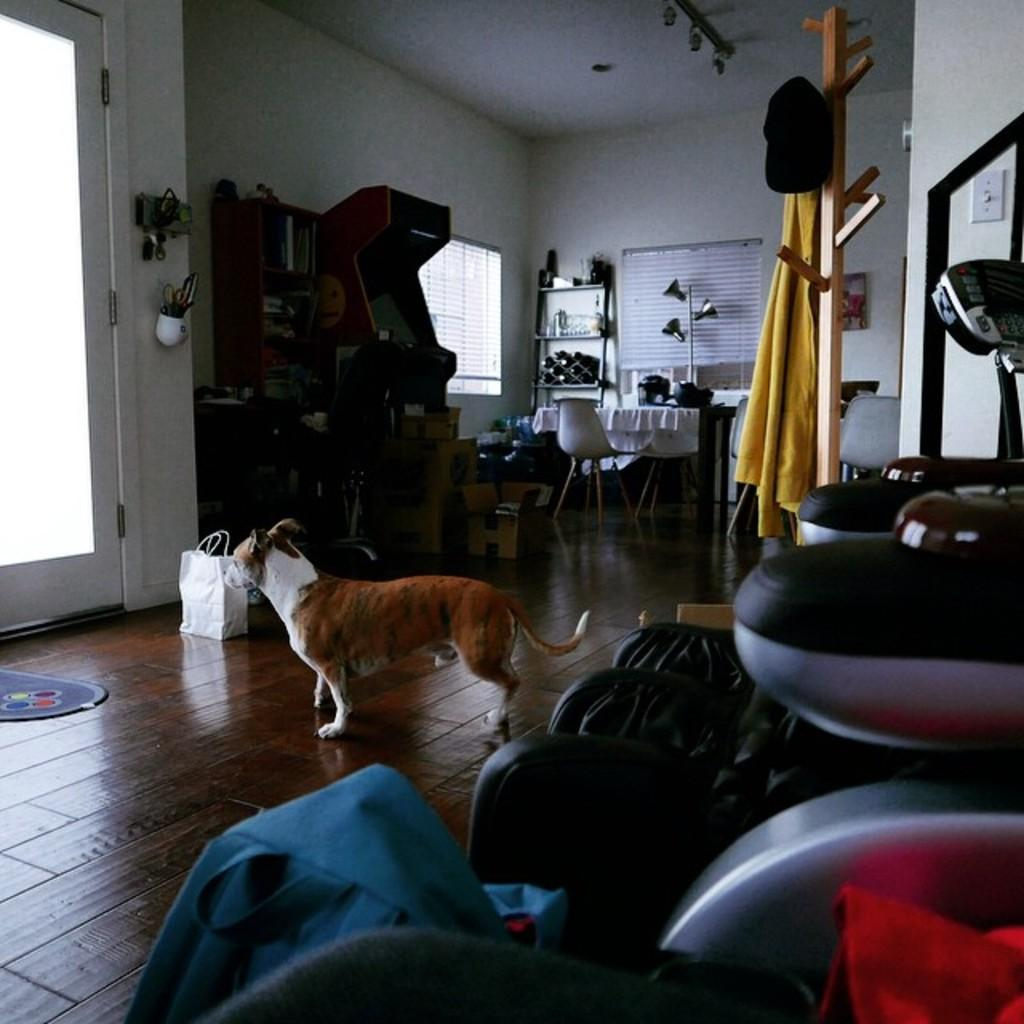What animal can be seen on the floor in the image? There is a dog on the floor in the image. What type of object is present in the image that can be used for carrying items? There is a bag in the image that can be used for carrying items. What type of furniture is visible in the image? There is a chair and a table in the image. What type of material is present in the image? There is cloth in the image. What type of clothing accessory is present in the image? There is a cap in the image. What type of storage or shelving is present in the image? There are racks in the image. What type of opening is present in the image that allows light and air to enter? There is a window in the image. What type of entrance or exit is present in the image? There is a door in the image. What type of vertical surface is present in the image? There is a wall in the image. How many books are stacked on the dog in the image? There are no books present in the image, so it is not possible to determine how many books might be stacked on the dog. 